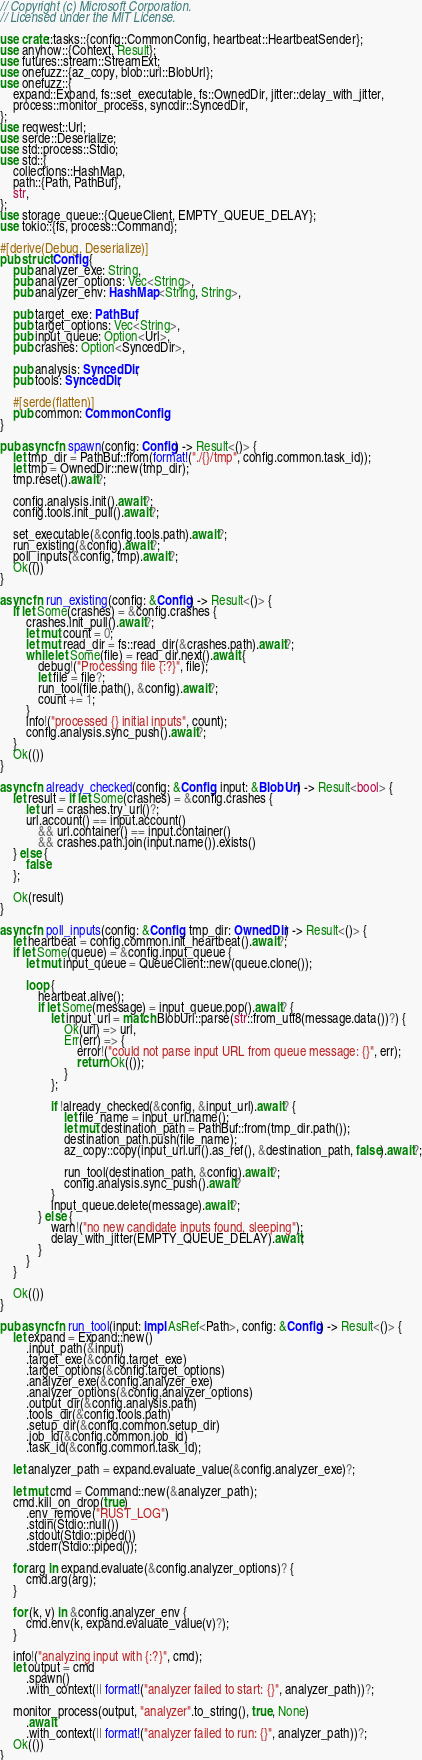<code> <loc_0><loc_0><loc_500><loc_500><_Rust_>// Copyright (c) Microsoft Corporation.
// Licensed under the MIT License.

use crate::tasks::{config::CommonConfig, heartbeat::HeartbeatSender};
use anyhow::{Context, Result};
use futures::stream::StreamExt;
use onefuzz::{az_copy, blob::url::BlobUrl};
use onefuzz::{
    expand::Expand, fs::set_executable, fs::OwnedDir, jitter::delay_with_jitter,
    process::monitor_process, syncdir::SyncedDir,
};
use reqwest::Url;
use serde::Deserialize;
use std::process::Stdio;
use std::{
    collections::HashMap,
    path::{Path, PathBuf},
    str,
};
use storage_queue::{QueueClient, EMPTY_QUEUE_DELAY};
use tokio::{fs, process::Command};

#[derive(Debug, Deserialize)]
pub struct Config {
    pub analyzer_exe: String,
    pub analyzer_options: Vec<String>,
    pub analyzer_env: HashMap<String, String>,

    pub target_exe: PathBuf,
    pub target_options: Vec<String>,
    pub input_queue: Option<Url>,
    pub crashes: Option<SyncedDir>,

    pub analysis: SyncedDir,
    pub tools: SyncedDir,

    #[serde(flatten)]
    pub common: CommonConfig,
}

pub async fn spawn(config: Config) -> Result<()> {
    let tmp_dir = PathBuf::from(format!("./{}/tmp", config.common.task_id));
    let tmp = OwnedDir::new(tmp_dir);
    tmp.reset().await?;

    config.analysis.init().await?;
    config.tools.init_pull().await?;

    set_executable(&config.tools.path).await?;
    run_existing(&config).await?;
    poll_inputs(&config, tmp).await?;
    Ok(())
}

async fn run_existing(config: &Config) -> Result<()> {
    if let Some(crashes) = &config.crashes {
        crashes.init_pull().await?;
        let mut count = 0;
        let mut read_dir = fs::read_dir(&crashes.path).await?;
        while let Some(file) = read_dir.next().await {
            debug!("Processing file {:?}", file);
            let file = file?;
            run_tool(file.path(), &config).await?;
            count += 1;
        }
        info!("processed {} initial inputs", count);
        config.analysis.sync_push().await?;
    }
    Ok(())
}

async fn already_checked(config: &Config, input: &BlobUrl) -> Result<bool> {
    let result = if let Some(crashes) = &config.crashes {
        let url = crashes.try_url()?;
        url.account() == input.account()
            && url.container() == input.container()
            && crashes.path.join(input.name()).exists()
    } else {
        false
    };

    Ok(result)
}

async fn poll_inputs(config: &Config, tmp_dir: OwnedDir) -> Result<()> {
    let heartbeat = config.common.init_heartbeat().await?;
    if let Some(queue) = &config.input_queue {
        let mut input_queue = QueueClient::new(queue.clone());

        loop {
            heartbeat.alive();
            if let Some(message) = input_queue.pop().await? {
                let input_url = match BlobUrl::parse(str::from_utf8(message.data())?) {
                    Ok(url) => url,
                    Err(err) => {
                        error!("could not parse input URL from queue message: {}", err);
                        return Ok(());
                    }
                };

                if !already_checked(&config, &input_url).await? {
                    let file_name = input_url.name();
                    let mut destination_path = PathBuf::from(tmp_dir.path());
                    destination_path.push(file_name);
                    az_copy::copy(input_url.url().as_ref(), &destination_path, false).await?;

                    run_tool(destination_path, &config).await?;
                    config.analysis.sync_push().await?
                }
                input_queue.delete(message).await?;
            } else {
                warn!("no new candidate inputs found, sleeping");
                delay_with_jitter(EMPTY_QUEUE_DELAY).await;
            }
        }
    }

    Ok(())
}

pub async fn run_tool(input: impl AsRef<Path>, config: &Config) -> Result<()> {
    let expand = Expand::new()
        .input_path(&input)
        .target_exe(&config.target_exe)
        .target_options(&config.target_options)
        .analyzer_exe(&config.analyzer_exe)
        .analyzer_options(&config.analyzer_options)
        .output_dir(&config.analysis.path)
        .tools_dir(&config.tools.path)
        .setup_dir(&config.common.setup_dir)
        .job_id(&config.common.job_id)
        .task_id(&config.common.task_id);

    let analyzer_path = expand.evaluate_value(&config.analyzer_exe)?;

    let mut cmd = Command::new(&analyzer_path);
    cmd.kill_on_drop(true)
        .env_remove("RUST_LOG")
        .stdin(Stdio::null())
        .stdout(Stdio::piped())
        .stderr(Stdio::piped());

    for arg in expand.evaluate(&config.analyzer_options)? {
        cmd.arg(arg);
    }

    for (k, v) in &config.analyzer_env {
        cmd.env(k, expand.evaluate_value(v)?);
    }

    info!("analyzing input with {:?}", cmd);
    let output = cmd
        .spawn()
        .with_context(|| format!("analyzer failed to start: {}", analyzer_path))?;

    monitor_process(output, "analyzer".to_string(), true, None)
        .await
        .with_context(|| format!("analyzer failed to run: {}", analyzer_path))?;
    Ok(())
}
</code> 